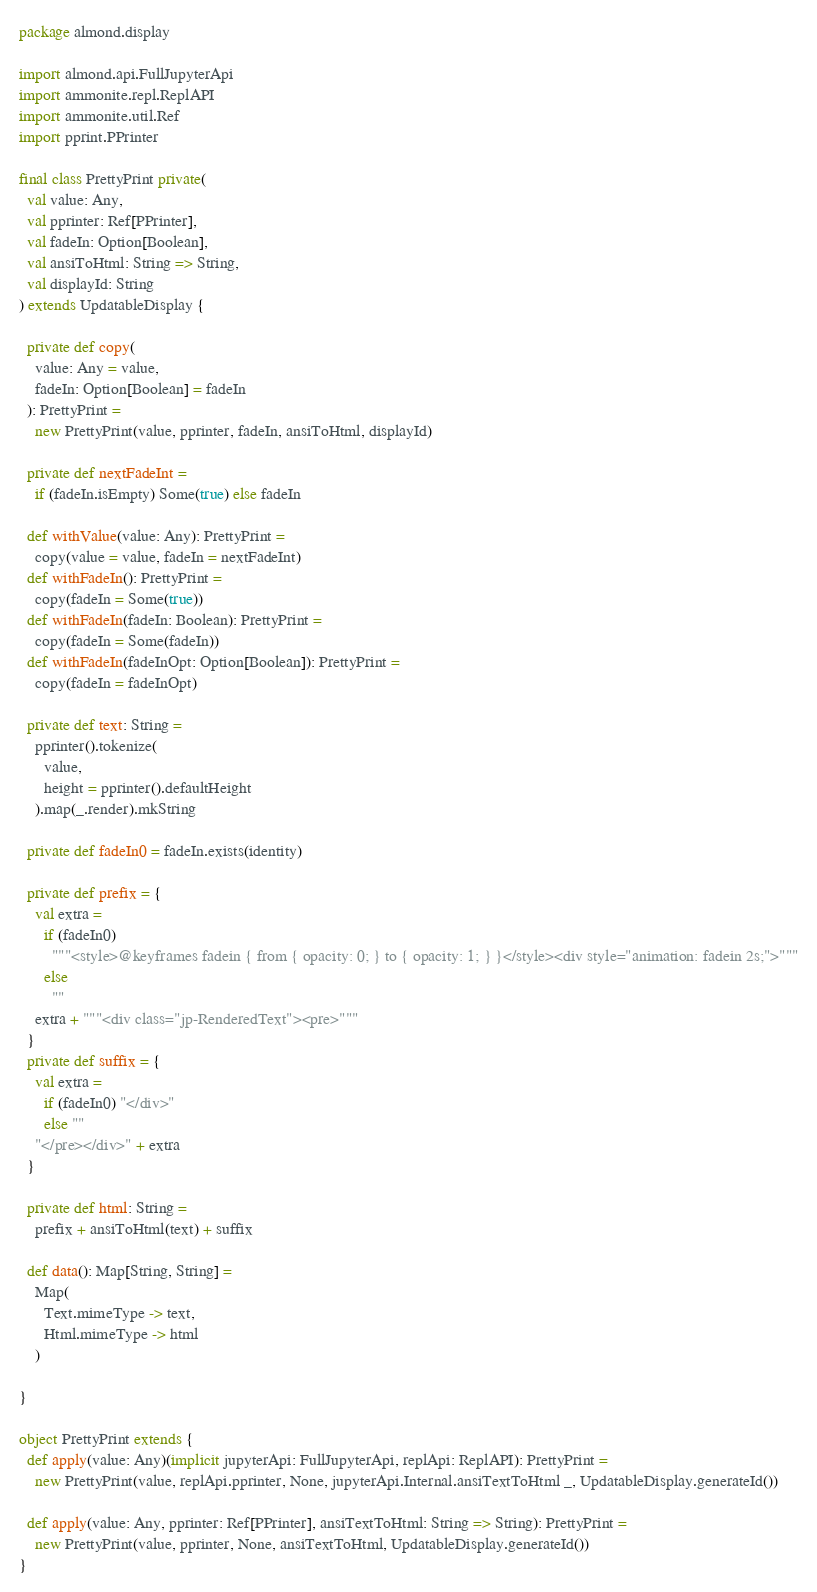Convert code to text. <code><loc_0><loc_0><loc_500><loc_500><_Scala_>package almond.display

import almond.api.FullJupyterApi
import ammonite.repl.ReplAPI
import ammonite.util.Ref
import pprint.PPrinter

final class PrettyPrint private(
  val value: Any,
  val pprinter: Ref[PPrinter],
  val fadeIn: Option[Boolean],
  val ansiToHtml: String => String,
  val displayId: String
) extends UpdatableDisplay {

  private def copy(
    value: Any = value,
    fadeIn: Option[Boolean] = fadeIn
  ): PrettyPrint =
    new PrettyPrint(value, pprinter, fadeIn, ansiToHtml, displayId)

  private def nextFadeInt =
    if (fadeIn.isEmpty) Some(true) else fadeIn

  def withValue(value: Any): PrettyPrint =
    copy(value = value, fadeIn = nextFadeInt)
  def withFadeIn(): PrettyPrint =
    copy(fadeIn = Some(true))
  def withFadeIn(fadeIn: Boolean): PrettyPrint =
    copy(fadeIn = Some(fadeIn))
  def withFadeIn(fadeInOpt: Option[Boolean]): PrettyPrint =
    copy(fadeIn = fadeInOpt)

  private def text: String =
    pprinter().tokenize(
      value,
      height = pprinter().defaultHeight
    ).map(_.render).mkString

  private def fadeIn0 = fadeIn.exists(identity)

  private def prefix = {
    val extra =
      if (fadeIn0)
        """<style>@keyframes fadein { from { opacity: 0; } to { opacity: 1; } }</style><div style="animation: fadein 2s;">"""
      else
        ""
    extra + """<div class="jp-RenderedText"><pre>"""
  }
  private def suffix = {
    val extra =
      if (fadeIn0) "</div>"
      else ""
    "</pre></div>" + extra
  }

  private def html: String =
    prefix + ansiToHtml(text) + suffix

  def data(): Map[String, String] =
    Map(
      Text.mimeType -> text,
      Html.mimeType -> html
    )

}

object PrettyPrint extends {
  def apply(value: Any)(implicit jupyterApi: FullJupyterApi, replApi: ReplAPI): PrettyPrint =
    new PrettyPrint(value, replApi.pprinter, None, jupyterApi.Internal.ansiTextToHtml _, UpdatableDisplay.generateId())

  def apply(value: Any, pprinter: Ref[PPrinter], ansiTextToHtml: String => String): PrettyPrint =
    new PrettyPrint(value, pprinter, None, ansiTextToHtml, UpdatableDisplay.generateId())
}
</code> 